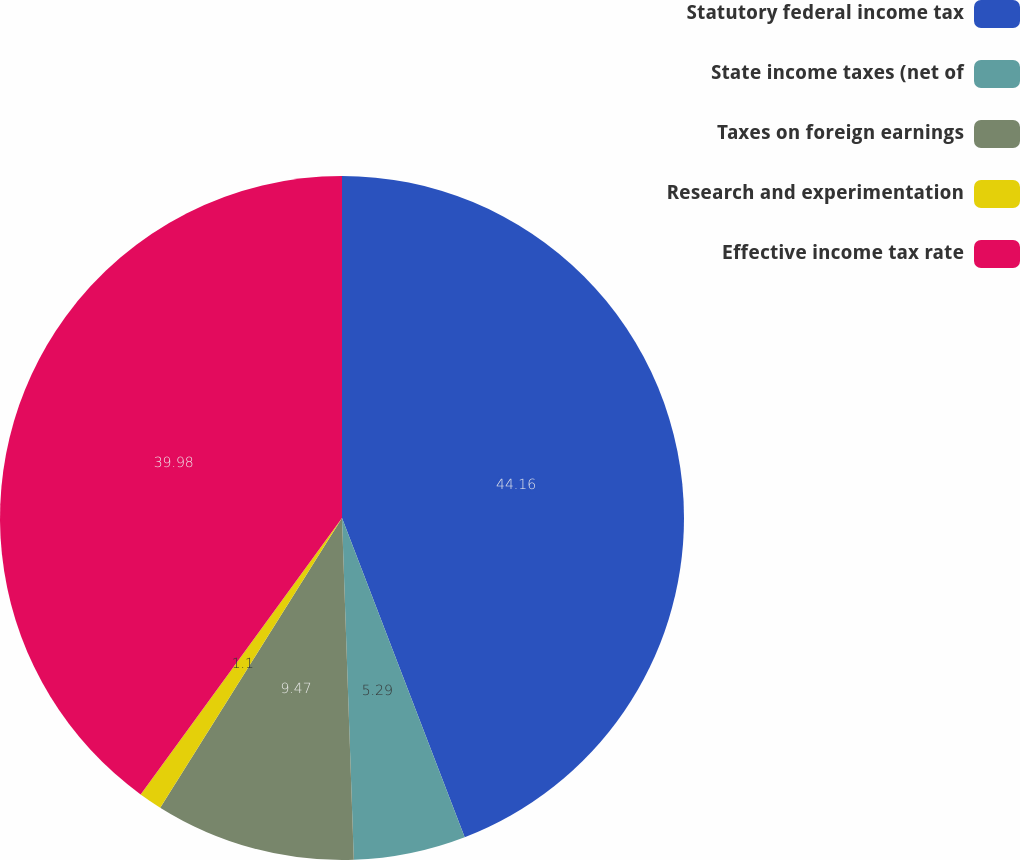Convert chart to OTSL. <chart><loc_0><loc_0><loc_500><loc_500><pie_chart><fcel>Statutory federal income tax<fcel>State income taxes (net of<fcel>Taxes on foreign earnings<fcel>Research and experimentation<fcel>Effective income tax rate<nl><fcel>44.16%<fcel>5.29%<fcel>9.47%<fcel>1.1%<fcel>39.98%<nl></chart> 